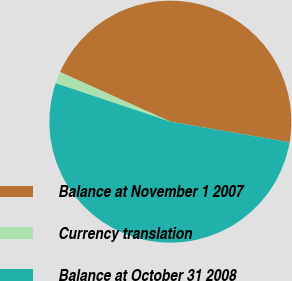Convert chart to OTSL. <chart><loc_0><loc_0><loc_500><loc_500><pie_chart><fcel>Balance at November 1 2007<fcel>Currency translation<fcel>Balance at October 31 2008<nl><fcel>46.0%<fcel>1.57%<fcel>52.42%<nl></chart> 